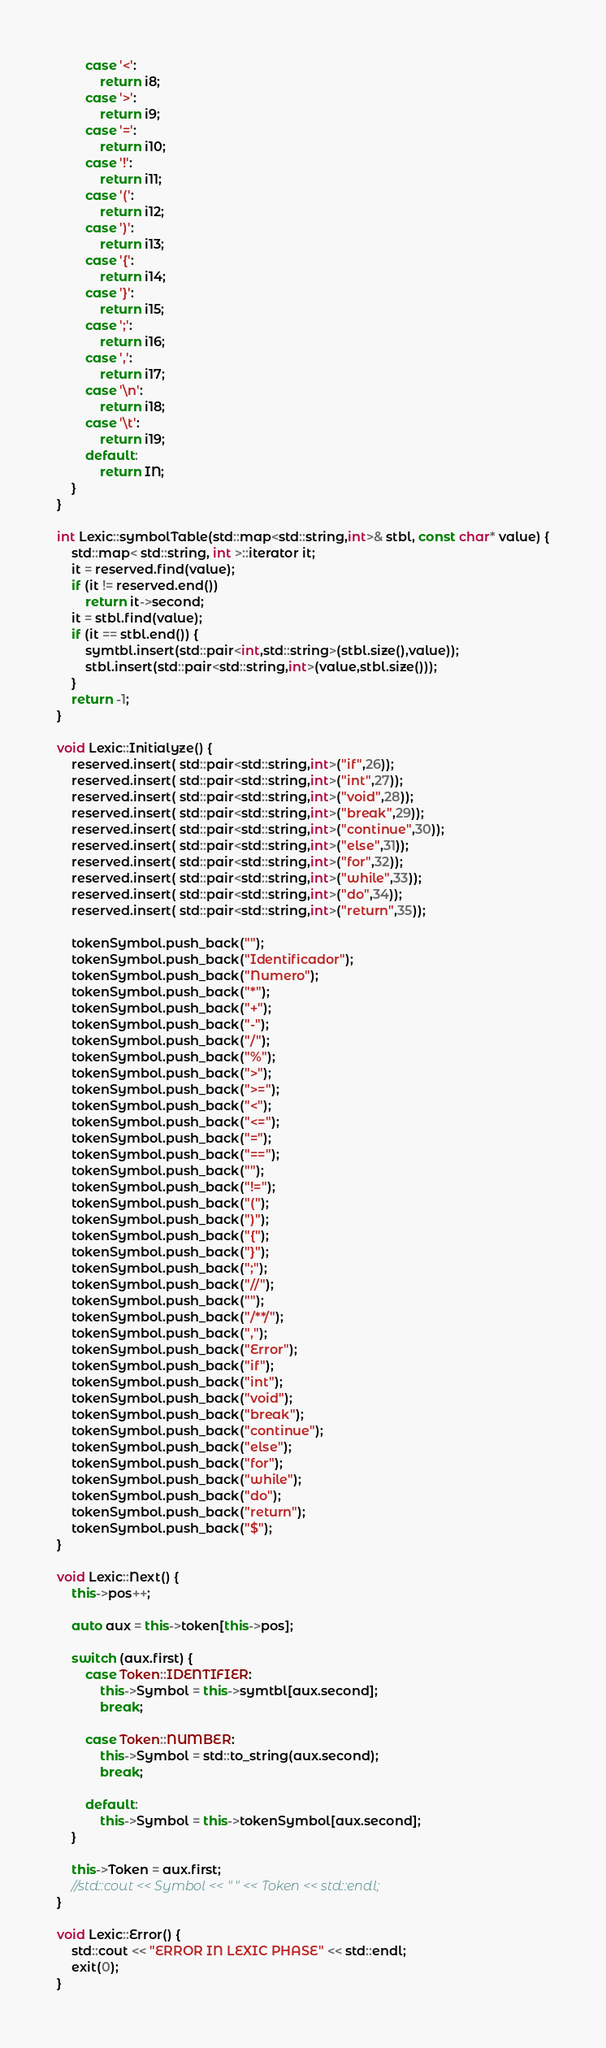<code> <loc_0><loc_0><loc_500><loc_500><_C++_>		case '<':
			return i8;
		case '>':
			return i9;
		case '=':
			return i10;
		case '!':
			return i11;
		case '(':
			return i12;
		case ')':
			return i13;
		case '{':
			return i14;
		case '}':
			return i15;
		case ';':
			return i16;
		case ',':
			return i17;
		case '\n':
			return i18;
		case '\t':
			return i19;
		default:
			return IN;
	}
}

int Lexic::symbolTable(std::map<std::string,int>& stbl, const char* value) {
	std::map< std::string, int >::iterator it;
	it = reserved.find(value);
	if (it != reserved.end())
		return it->second;
	it = stbl.find(value);
	if (it == stbl.end()) {
		symtbl.insert(std::pair<int,std::string>(stbl.size(),value));
		stbl.insert(std::pair<std::string,int>(value,stbl.size()));
	}
	return -1;
}

void Lexic::Initialyze() {
	reserved.insert( std::pair<std::string,int>("if",26));
	reserved.insert( std::pair<std::string,int>("int",27));
	reserved.insert( std::pair<std::string,int>("void",28));
	reserved.insert( std::pair<std::string,int>("break",29));
	reserved.insert( std::pair<std::string,int>("continue",30));
	reserved.insert( std::pair<std::string,int>("else",31));
	reserved.insert( std::pair<std::string,int>("for",32));
	reserved.insert( std::pair<std::string,int>("while",33));
	reserved.insert( std::pair<std::string,int>("do",34));
	reserved.insert( std::pair<std::string,int>("return",35));

	tokenSymbol.push_back("");
	tokenSymbol.push_back("Identificador");
	tokenSymbol.push_back("Numero");
	tokenSymbol.push_back("*");
	tokenSymbol.push_back("+");
	tokenSymbol.push_back("-");
	tokenSymbol.push_back("/");
	tokenSymbol.push_back("%");
	tokenSymbol.push_back(">");
	tokenSymbol.push_back(">=");
	tokenSymbol.push_back("<");
	tokenSymbol.push_back("<=");
	tokenSymbol.push_back("=");
	tokenSymbol.push_back("==");
	tokenSymbol.push_back("");
	tokenSymbol.push_back("!=");
	tokenSymbol.push_back("(");
	tokenSymbol.push_back(")");
	tokenSymbol.push_back("{");
	tokenSymbol.push_back("}");
	tokenSymbol.push_back(";");
	tokenSymbol.push_back("//");
	tokenSymbol.push_back("");
	tokenSymbol.push_back("/**/");
	tokenSymbol.push_back(",");
	tokenSymbol.push_back("Error");
	tokenSymbol.push_back("if");
	tokenSymbol.push_back("int");
	tokenSymbol.push_back("void");
	tokenSymbol.push_back("break");
	tokenSymbol.push_back("continue");
	tokenSymbol.push_back("else");
	tokenSymbol.push_back("for");
	tokenSymbol.push_back("while");
	tokenSymbol.push_back("do");
	tokenSymbol.push_back("return");
	tokenSymbol.push_back("$");
}

void Lexic::Next() {
	this->pos++;

	auto aux = this->token[this->pos];

	switch (aux.first) {
		case Token::IDENTIFIER:
			this->Symbol = this->symtbl[aux.second];
			break;

		case Token::NUMBER:
			this->Symbol = std::to_string(aux.second);
			break;

		default:
			this->Symbol = this->tokenSymbol[aux.second];
	}

	this->Token = aux.first;
	//std::cout << Symbol << " " << Token << std::endl;
}

void Lexic::Error() {
	std::cout << "ERROR IN LEXIC PHASE" << std::endl;
	exit(0);
}
</code> 